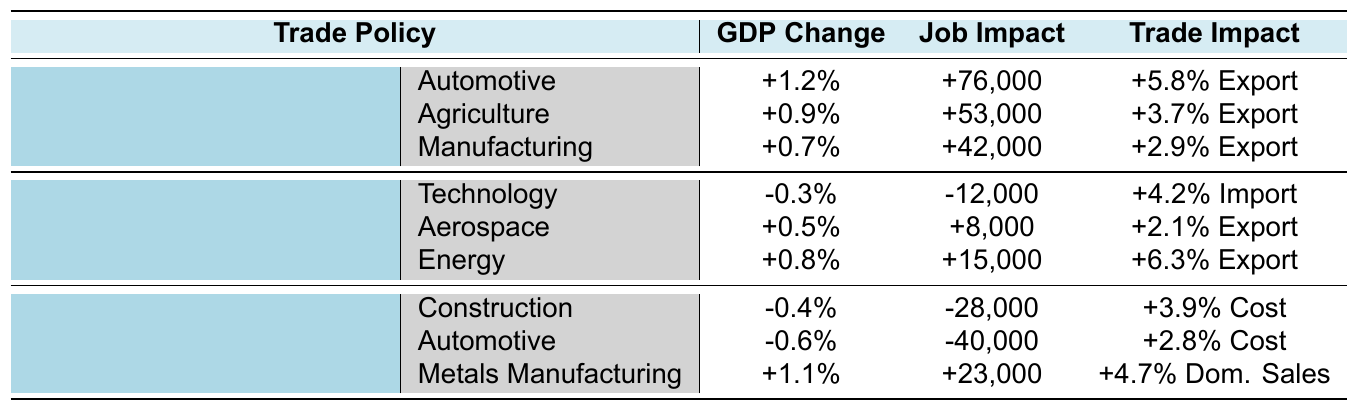What is the GDP change for the Automotive sector under the USMCA policy? The USMCA policy has a listed GDP change of +1.2% for the Automotive sector in the table.
Answer: +1.2% How many jobs are created in the Agriculture sector due to the USMCA policy? The table indicates that the Agriculture sector sees a job creation of +53,000 under the USMCA policy.
Answer: +53,000 What is the impact on GDP for Technology under the US-China Phase One Trade Deal? The table shows that the Technology sector experiences a GDP change of -0.3% under the US-China Phase One Trade Deal.
Answer: -0.3% Which sector is predicted to lose the most jobs under the Steel and Aluminum Tariffs? The Automotive sector loses -40,000 jobs, while the Construction sector loses -28,000 jobs, making Automotive the largest job loser under the Steel and Aluminum Tariffs.
Answer: Automotive What is the combined job creation from the USMCA policy across all sectors? For the USMCA policy, the job creation values are +76,000 (Automotive) + +53,000 (Agriculture) + +42,000 (Manufacturing) = +171,000.
Answer: +171,000 Is there any sector listed under the US-China Phase One Trade Deal showing a GDP increase? Yes, both Aerospace (+0.5%) and Energy (+0.8%) sectors show a GDP increase under the US-China Phase One Trade Deal, hence, the statement is true.
Answer: Yes Which trade policy leads to a cost increase in the Construction sector? The Steel and Aluminum Tariffs policy leads to a cost increase of +3.9% in the Construction sector as indicated in the table.
Answer: Steel and Aluminum Tariffs What is the total number of jobs created in the Metals Manufacturing sector under the Steel and Aluminum Tariffs? The Metals Manufacturing sector under this policy has a job creation of +23,000 as per the table.
Answer: +23,000 How does the GDP change for the Energy sector compare to the job change in the same sector under the US-China Phase One Trade Deal? The GDP change for the Energy sector is +0.8% while the job change is +15,000. This indicates a positive impact on GDP alongside job creation.
Answer: Positive impact What is the net job impact across all sectors for the US-China Phase One Trade Deal? The net job impact can be calculated as: -12,000 (Technology) + 8,000 (Aerospace) + 15,000 (Energy) = +11,000 jobs overall.
Answer: +11,000 